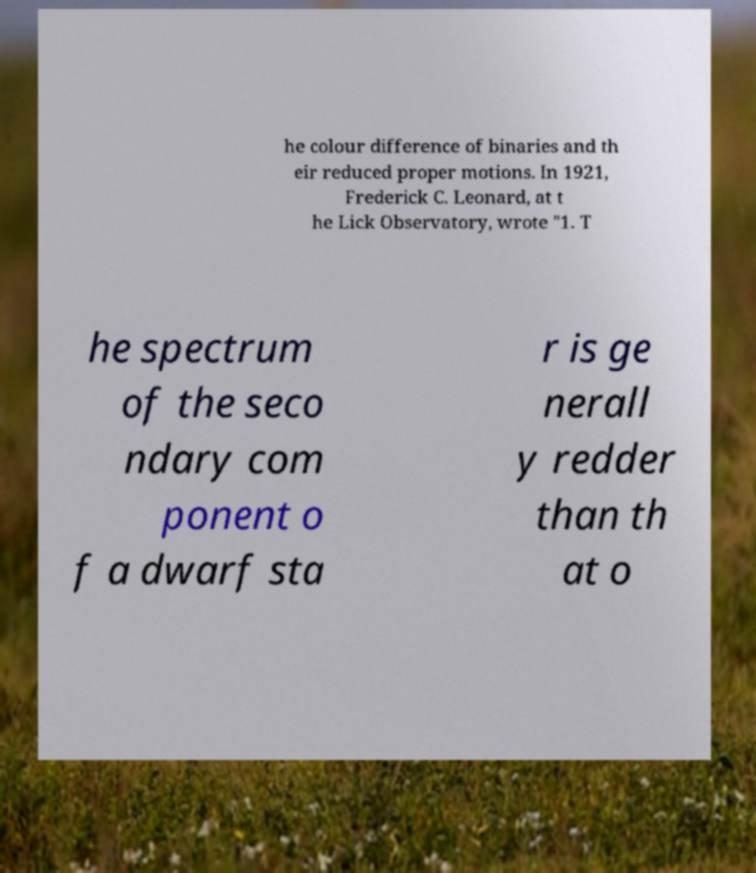Could you extract and type out the text from this image? he colour difference of binaries and th eir reduced proper motions. In 1921, Frederick C. Leonard, at t he Lick Observatory, wrote "1. T he spectrum of the seco ndary com ponent o f a dwarf sta r is ge nerall y redder than th at o 